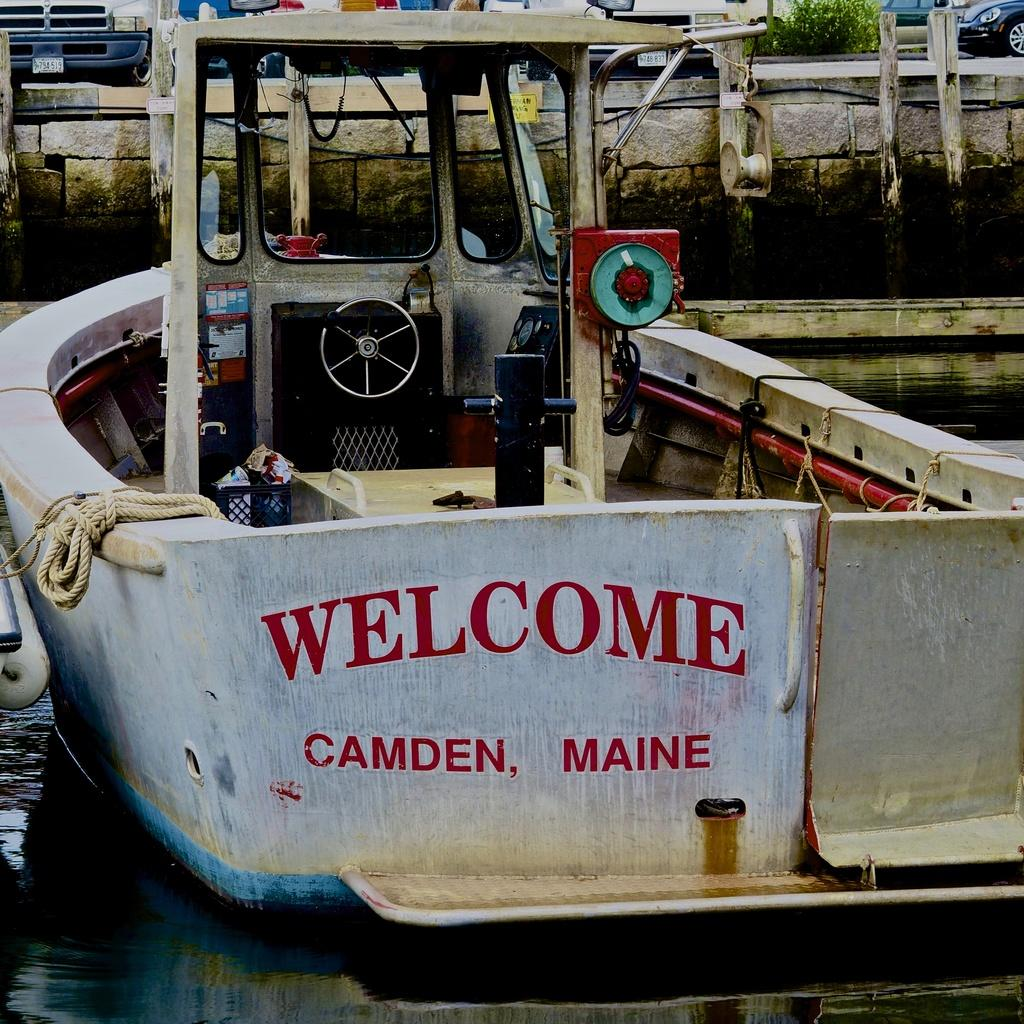What is the main subject in the center of the image? There is a ship in the center of the image. What can be seen at the bottom of the image? There is water visible at the bottom of the image. What type of hammer can be seen being used on the train tracks in the image? There is no hammer or train tracks present in the image; it features a ship and water. 